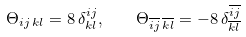Convert formula to latex. <formula><loc_0><loc_0><loc_500><loc_500>\Theta _ { i j \, k l } = 8 \, \delta ^ { i j } _ { k l } , \quad \Theta _ { \overline { i j } \, \overline { k l } } = - 8 \, \delta ^ { \overline { i j } } _ { \overline { k l } }</formula> 